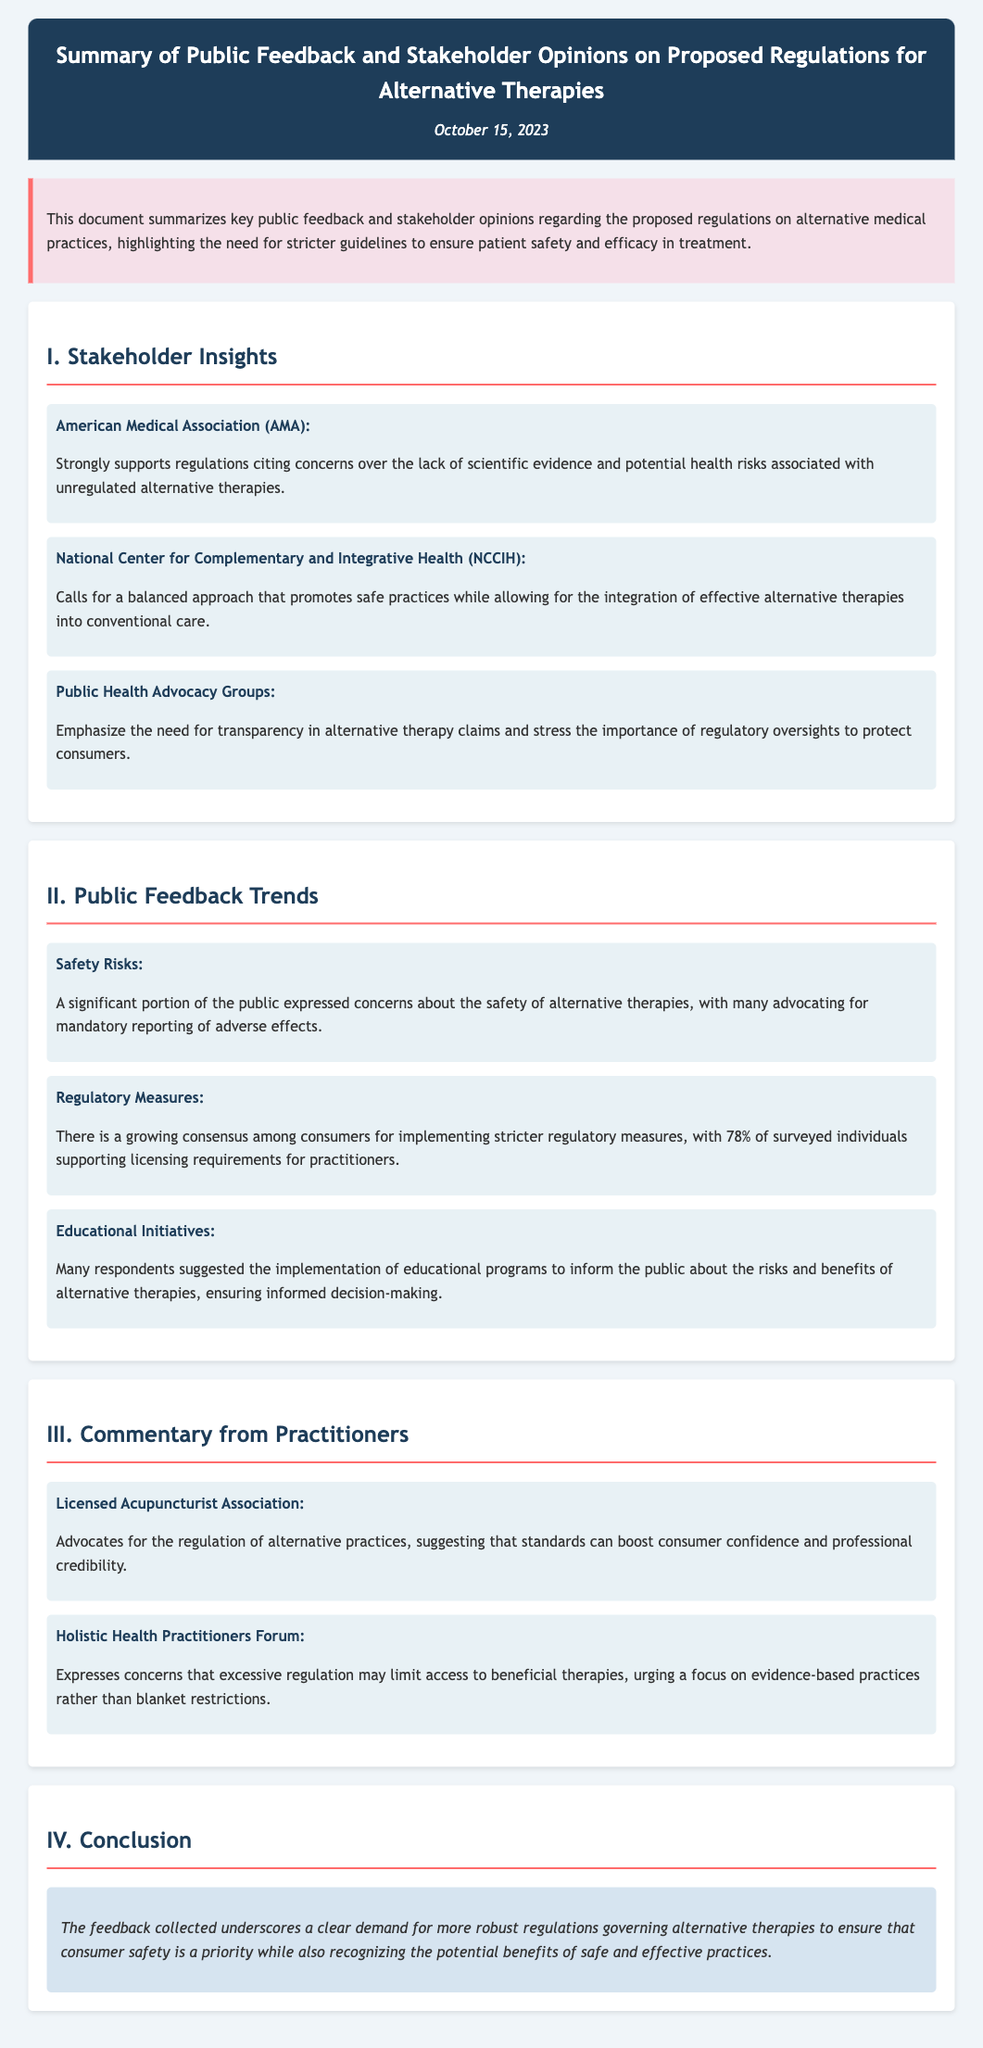what organization strongly supports regulations on alternative therapies? The American Medical Association (AMA) strongly supports regulations due to concerns over scientific evidence and health risks.
Answer: American Medical Association (AMA) what percentage of surveyed individuals supports licensing requirements for practitioners? The document states that 78% of surveyed individuals support licensing requirements for practitioners.
Answer: 78% what concern is emphasized by public health advocacy groups? Public health advocacy groups emphasize the need for transparency in alternative therapy claims.
Answer: Transparency what is a suggested initiative to inform the public about alternative therapies? Many respondents suggested implementing educational programs to inform the public about risks and benefits.
Answer: Educational programs who advocates for the regulation of alternative practices, suggesting it boosts consumer confidence? The Licensed Acupuncturist Association advocates for the regulation of alternative practices.
Answer: Licensed Acupuncturist Association what potential issue do holistic health practitioners express regarding excessive regulation? Holistic health practitioners express concerns that excessive regulation may limit access to beneficial therapies.
Answer: Limit access what is the main conclusion drawn from the feedback collected? The conclusion emphasizes the demand for robust regulations governing alternative therapies to ensure consumer safety.
Answer: Demand for robust regulations what is the date of the document? The document is dated October 15, 2023.
Answer: October 15, 2023 what is the background color of the overview section? The overview section has a light pink background color.
Answer: Light pink 